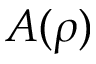Convert formula to latex. <formula><loc_0><loc_0><loc_500><loc_500>A ( \rho )</formula> 